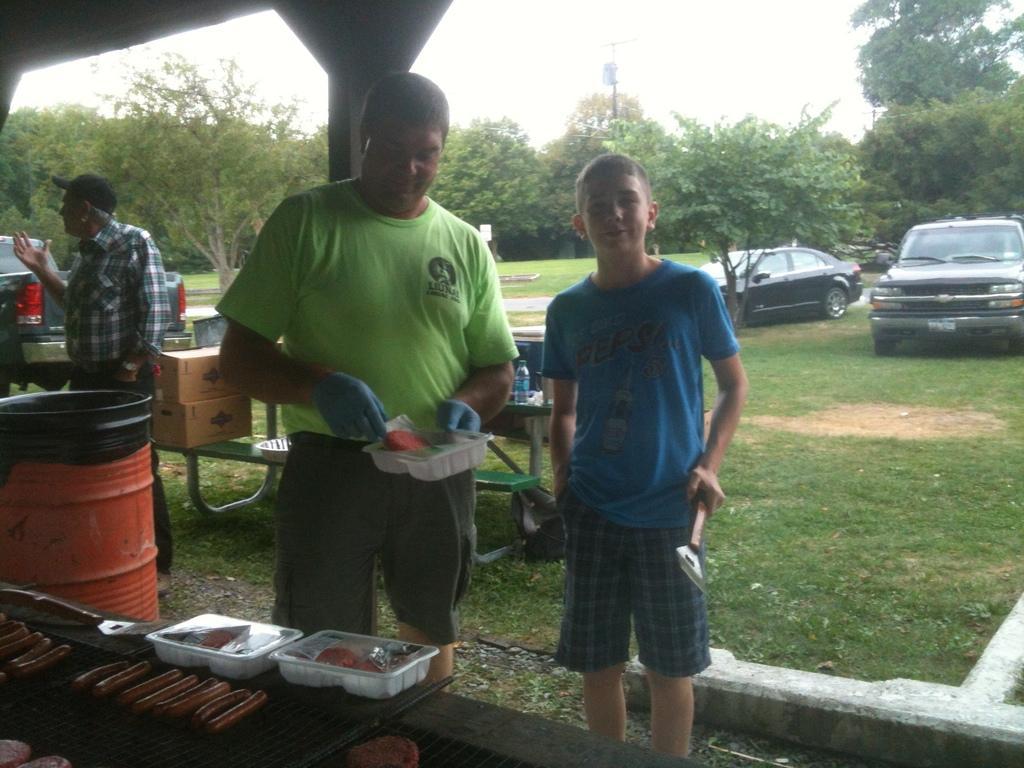Can you describe this image briefly? In this picture we can see three men standing and some cars behind them and some trees and the men holding some things in their hands. 